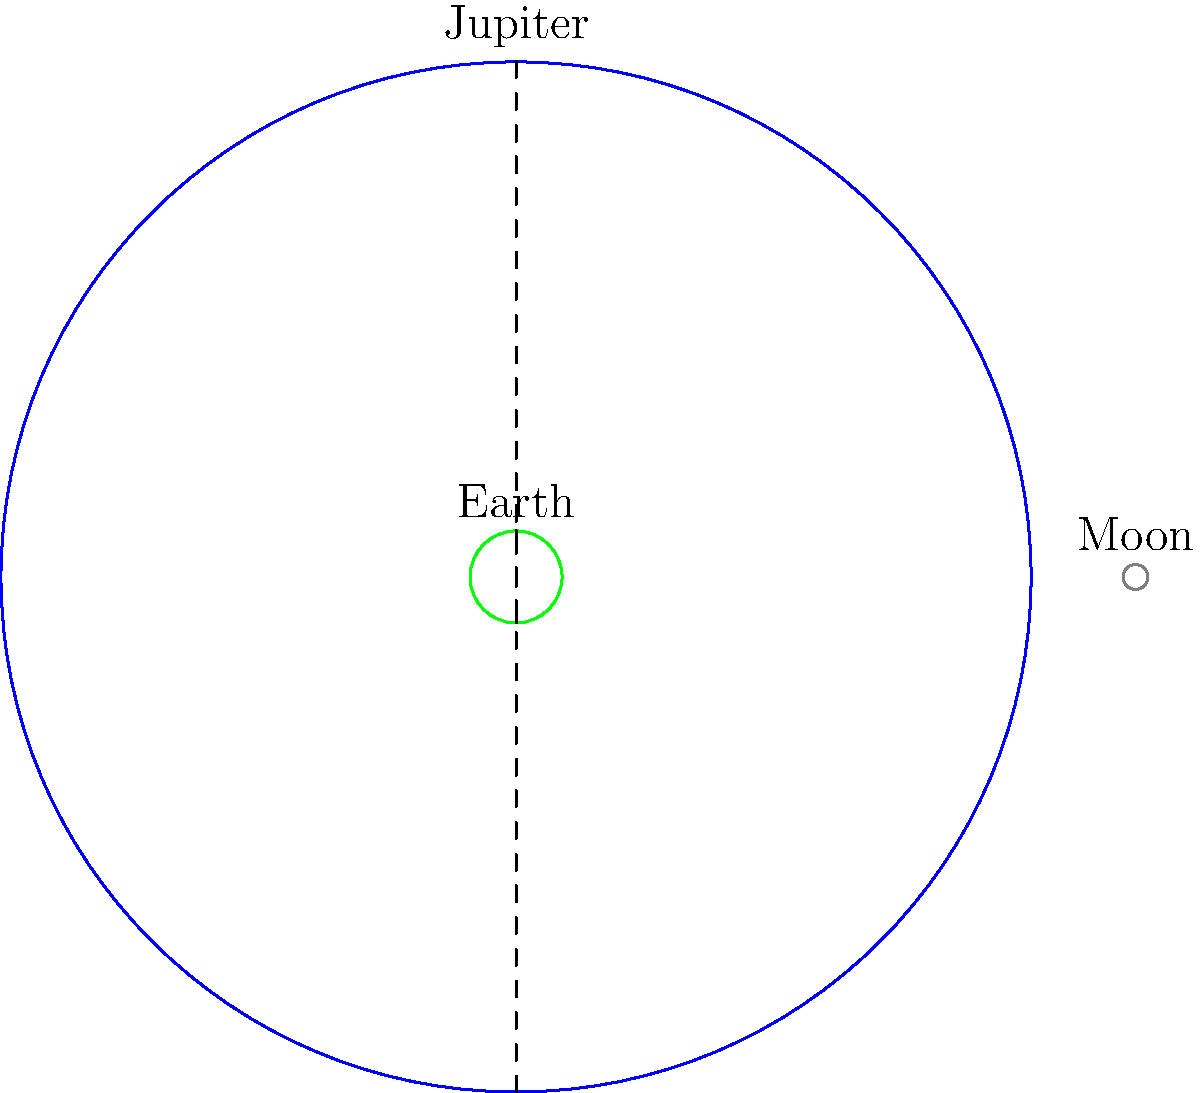In the scaled diagram above, Jupiter, Earth, and the Moon are represented to show their relative sizes. Based on your understanding of planetary scales and this visual representation, approximately how many Earths could fit inside Jupiter's volume? To determine how many Earths could fit inside Jupiter's volume, we need to follow these steps:

1. Recognize that the volume of a sphere is proportional to the cube of its radius.

2. From the diagram, we can see that Jupiter's radius is about 11.2 times that of Earth.

3. Calculate the volume ratio:
   $\text{Volume ratio} = (\frac{\text{Jupiter radius}}{\text{Earth radius}})^3$
   $= (11.2)^3 \approx 1,400$

4. This means that Jupiter's volume is about 1,400 times greater than Earth's volume.

5. Therefore, approximately 1,400 Earths could fit inside Jupiter.

While this might seem unrelated to paleontology, understanding scale in astronomy can provide context for the evolution of life on Earth and the conditions that led to the formation and preservation of the fossils you study.
Answer: Approximately 1,400 Earths 